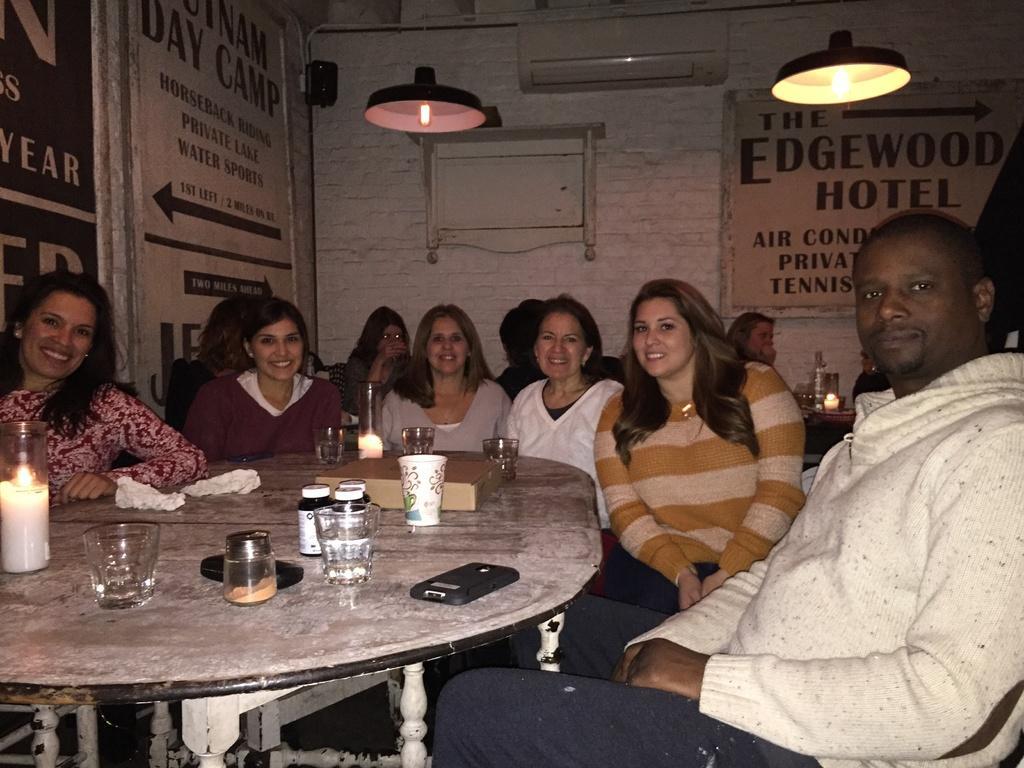Please provide a concise description of this image. In this picture we can see few persons sitting on the chairs in front of a table. we can see a candle, light, bottles, glass, containers and box , mobile on the table. On the background we can see a wall with white bricks. This is a AC. These are the lights. Behind theses persons we can see a woman sitting in front of a table. 